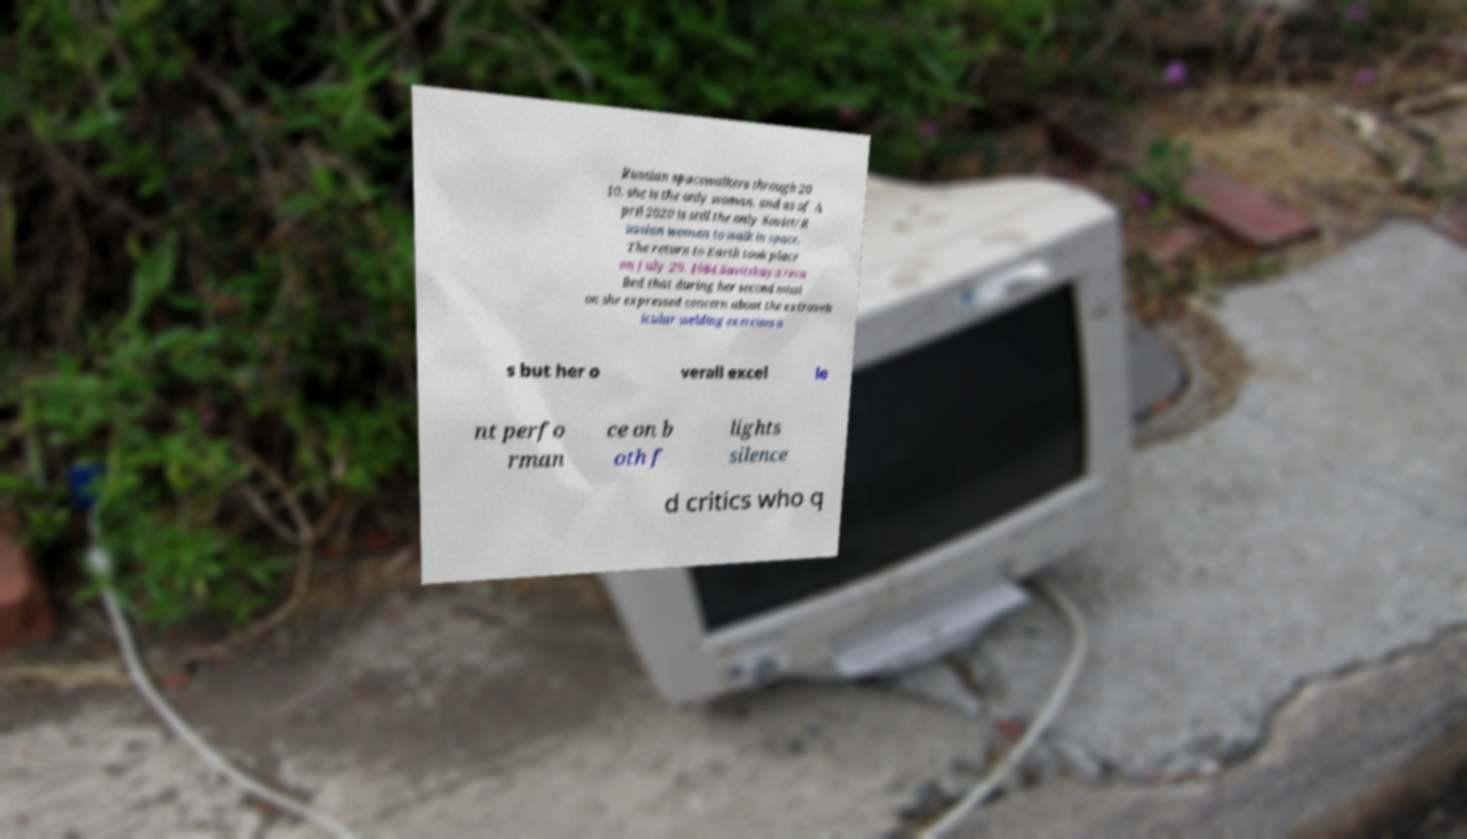Could you assist in decoding the text presented in this image and type it out clearly? Russian spacewalkers through 20 10, she is the only woman, and as of A pril 2020 is still the only Soviet/R ussian woman to walk in space. The return to Earth took place on July 29, 1984.Savitskaya reca lled that during her second missi on she expressed concern about the extraveh icular welding exercises a s but her o verall excel le nt perfo rman ce on b oth f lights silence d critics who q 